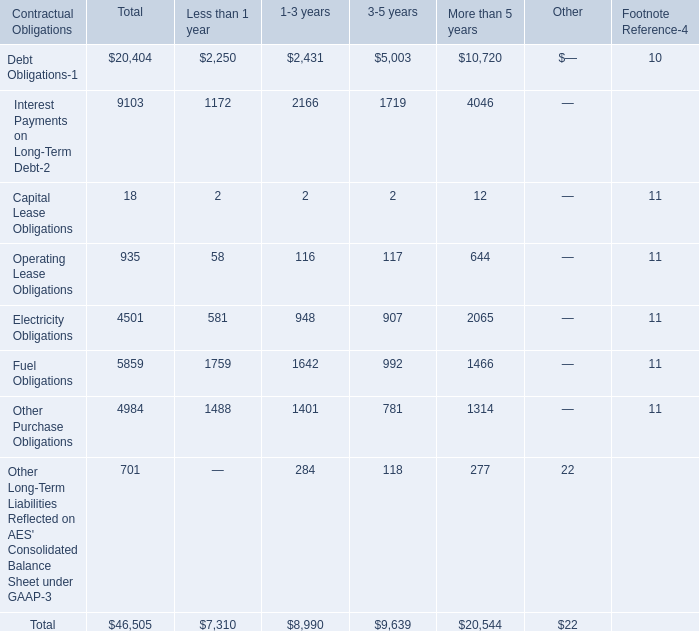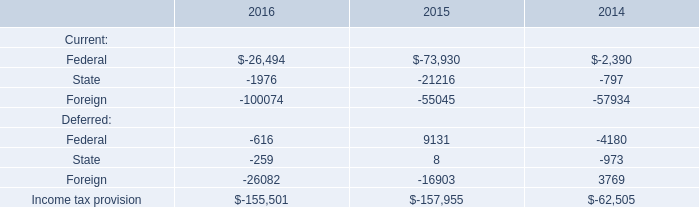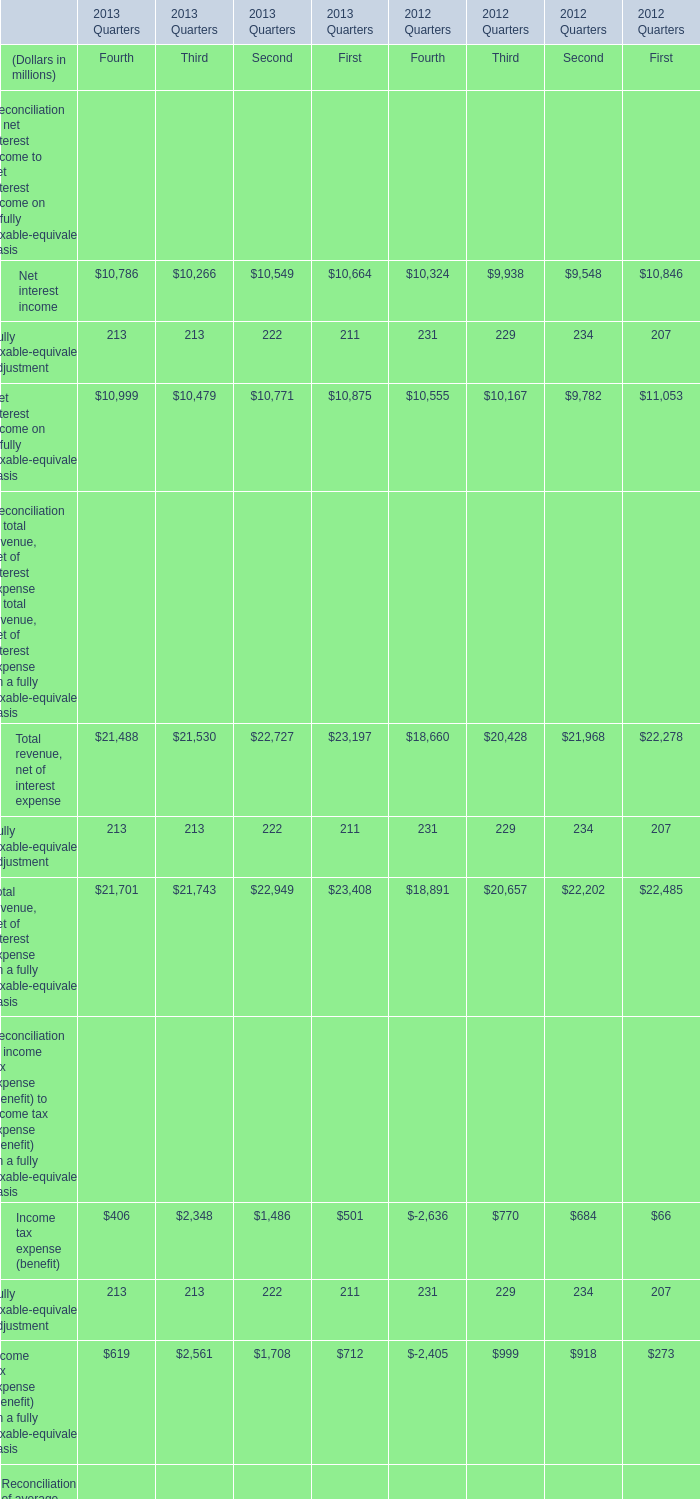What is the growing rate of Assets in the years with the least Fully taxable-equivalent adjustment ？ 
Computations: (((((2102273 + 2126653) + 2123320) + 2174819) - (((2209974 + 2166162) + 2160854) + 2181449)) / (((2209974 + 2166162) + 2160854) + 2181449))
Answer: -0.02195. 